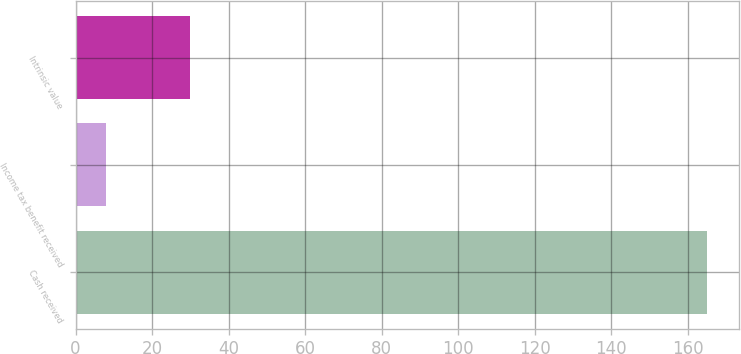Convert chart. <chart><loc_0><loc_0><loc_500><loc_500><bar_chart><fcel>Cash received<fcel>Income tax benefit received<fcel>Intrinsic value<nl><fcel>165<fcel>8<fcel>30<nl></chart> 